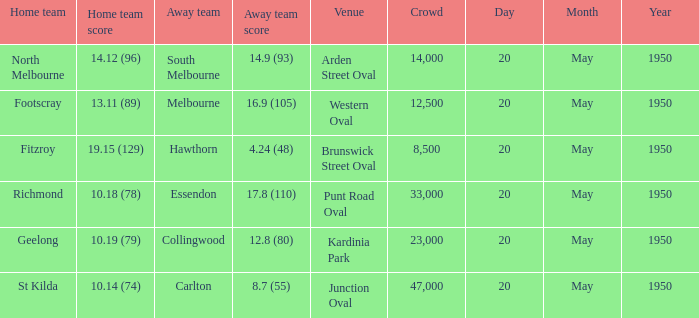9 (93)? Arden Street Oval. 